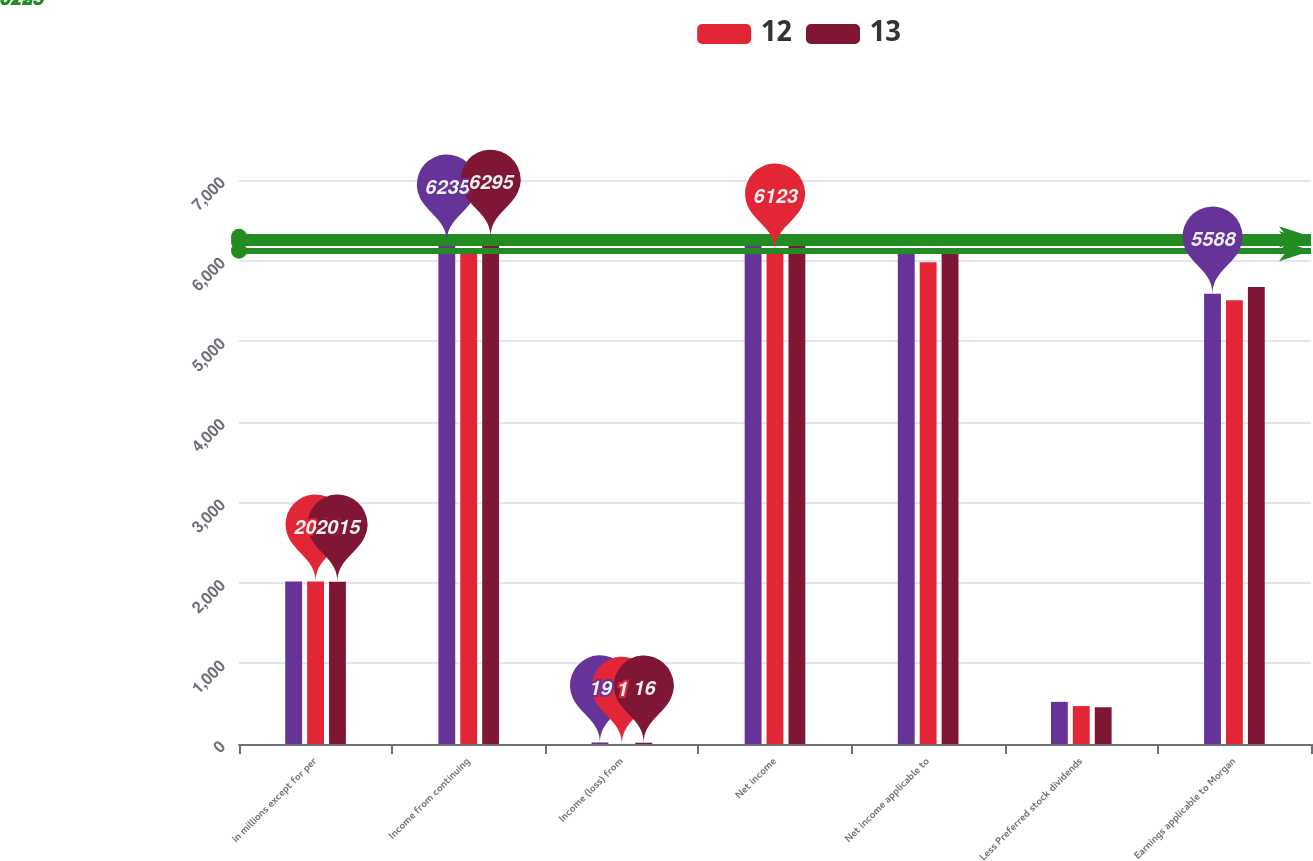Convert chart. <chart><loc_0><loc_0><loc_500><loc_500><stacked_bar_chart><ecel><fcel>in millions except for per<fcel>Income from continuing<fcel>Income (loss) from<fcel>Net income<fcel>Net income applicable to<fcel>Less Preferred stock dividends<fcel>Earnings applicable to Morgan<nl><fcel>nan<fcel>2017<fcel>6235<fcel>19<fcel>6216<fcel>6111<fcel>523<fcel>5588<nl><fcel>12<fcel>2016<fcel>6122<fcel>1<fcel>6123<fcel>5979<fcel>471<fcel>5508<nl><fcel>13<fcel>2015<fcel>6295<fcel>16<fcel>6279<fcel>6127<fcel>456<fcel>5671<nl></chart> 